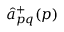Convert formula to latex. <formula><loc_0><loc_0><loc_500><loc_500>{ \hat { a } } _ { p q } ^ { + } ( p )</formula> 